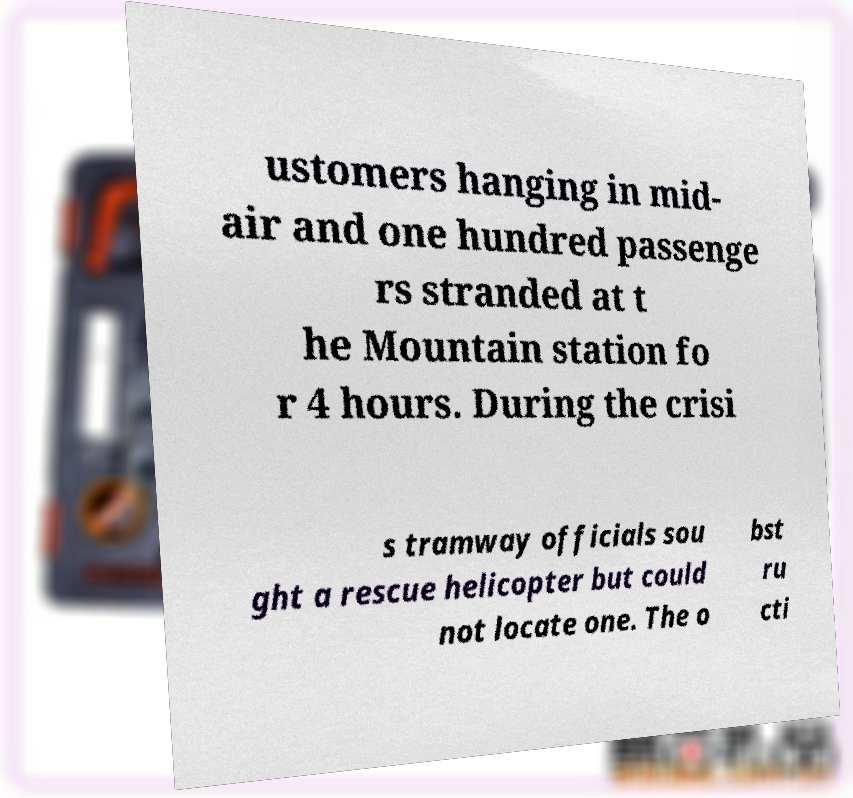Could you assist in decoding the text presented in this image and type it out clearly? ustomers hanging in mid- air and one hundred passenge rs stranded at t he Mountain station fo r 4 hours. During the crisi s tramway officials sou ght a rescue helicopter but could not locate one. The o bst ru cti 